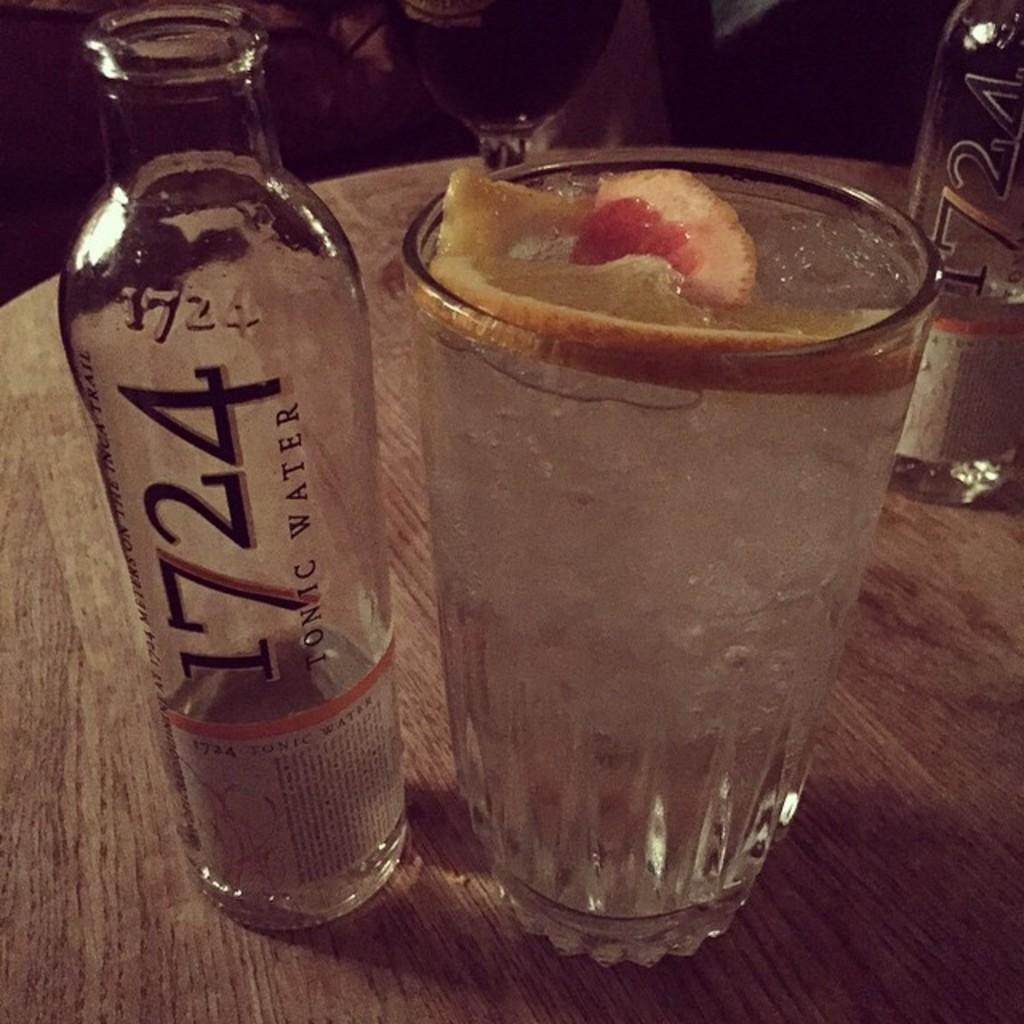<image>
Render a clear and concise summary of the photo. A clear bottle with 724 next to a glass. 